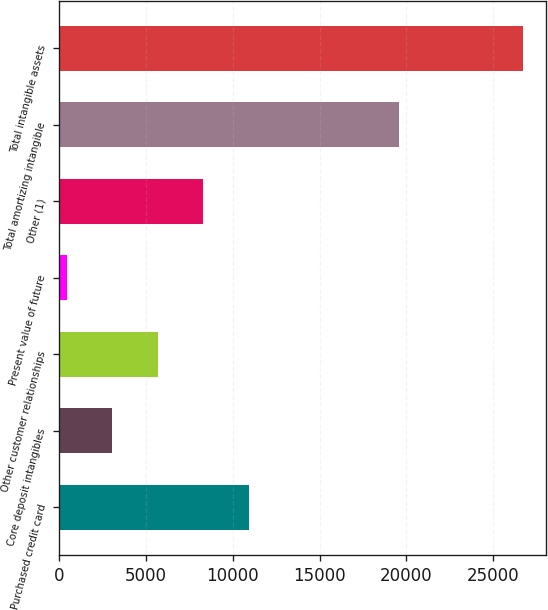Convert chart. <chart><loc_0><loc_0><loc_500><loc_500><bar_chart><fcel>Purchased credit card<fcel>Core deposit intangibles<fcel>Other customer relationships<fcel>Present value of future<fcel>Other (1)<fcel>Total amortizing intangible<fcel>Total intangible assets<nl><fcel>10932.2<fcel>3044.3<fcel>5673.6<fcel>415<fcel>8302.9<fcel>19577<fcel>26708<nl></chart> 